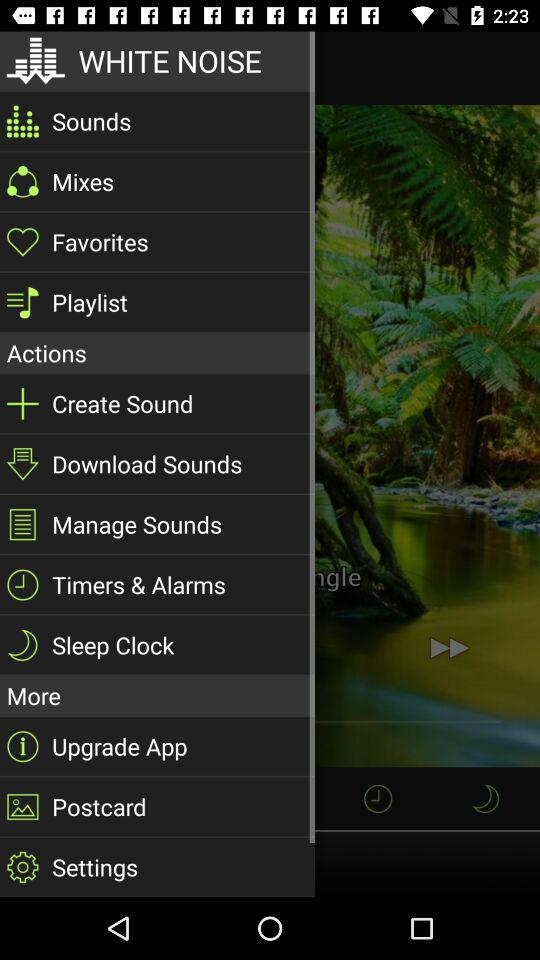What is the application name? The application name is "WHITE NOISE". 